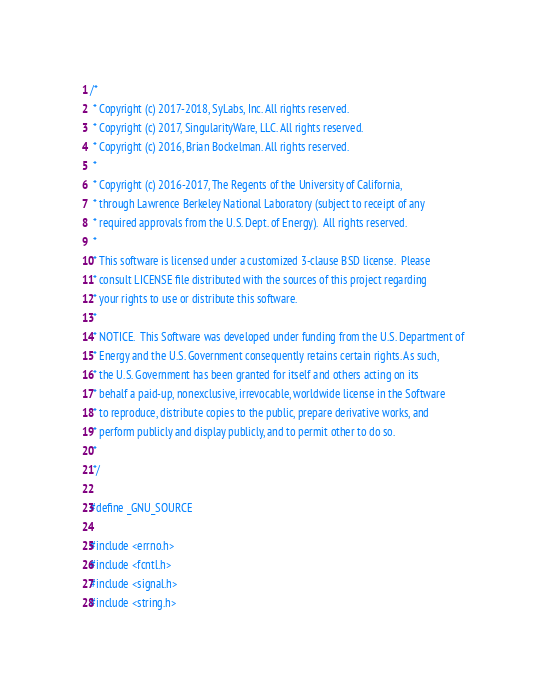Convert code to text. <code><loc_0><loc_0><loc_500><loc_500><_C_>/*
 * Copyright (c) 2017-2018, SyLabs, Inc. All rights reserved.
 * Copyright (c) 2017, SingularityWare, LLC. All rights reserved.
 * Copyright (c) 2016, Brian Bockelman. All rights reserved.
 *
 * Copyright (c) 2016-2017, The Regents of the University of California,
 * through Lawrence Berkeley National Laboratory (subject to receipt of any
 * required approvals from the U.S. Dept. of Energy).  All rights reserved.
 *
 * This software is licensed under a customized 3-clause BSD license.  Please
 * consult LICENSE file distributed with the sources of this project regarding
 * your rights to use or distribute this software.
 *
 * NOTICE.  This Software was developed under funding from the U.S. Department of
 * Energy and the U.S. Government consequently retains certain rights. As such,
 * the U.S. Government has been granted for itself and others acting on its
 * behalf a paid-up, nonexclusive, irrevocable, worldwide license in the Software
 * to reproduce, distribute copies to the public, prepare derivative works, and
 * perform publicly and display publicly, and to permit other to do so.
 *
 */

#define _GNU_SOURCE

#include <errno.h>
#include <fcntl.h>
#include <signal.h>
#include <string.h></code> 